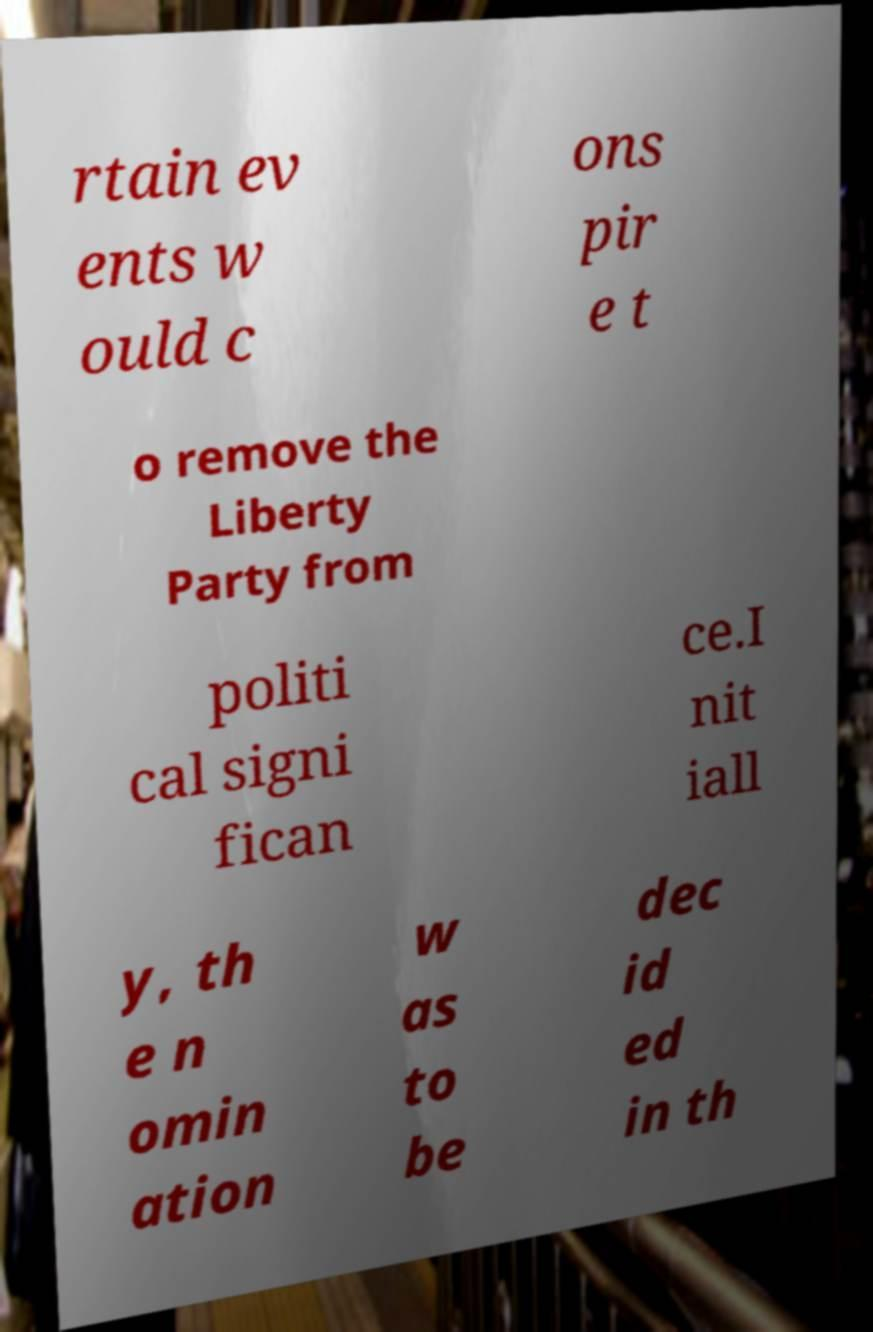What messages or text are displayed in this image? I need them in a readable, typed format. rtain ev ents w ould c ons pir e t o remove the Liberty Party from politi cal signi fican ce.I nit iall y, th e n omin ation w as to be dec id ed in th 